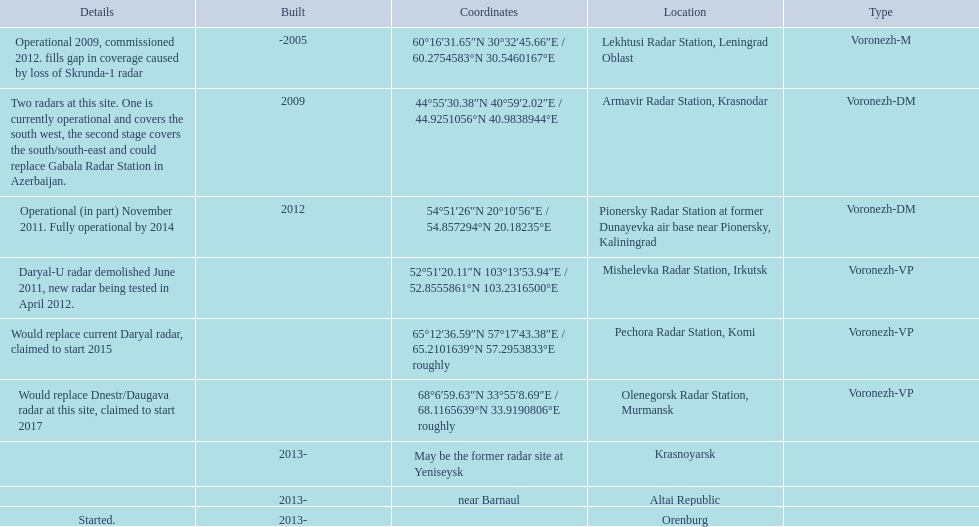What are all of the locations? Lekhtusi Radar Station, Leningrad Oblast, Armavir Radar Station, Krasnodar, Pionersky Radar Station at former Dunayevka air base near Pionersky, Kaliningrad, Mishelevka Radar Station, Irkutsk, Pechora Radar Station, Komi, Olenegorsk Radar Station, Murmansk, Krasnoyarsk, Altai Republic, Orenburg. Would you be able to parse every entry in this table? {'header': ['Details', 'Built', 'Coordinates', 'Location', 'Type'], 'rows': [['Operational 2009, commissioned 2012. fills gap in coverage caused by loss of Skrunda-1 radar', '-2005', '60°16′31.65″N 30°32′45.66″E\ufeff / \ufeff60.2754583°N 30.5460167°E', 'Lekhtusi Radar Station, Leningrad Oblast', 'Voronezh-M'], ['Two radars at this site. One is currently operational and covers the south west, the second stage covers the south/south-east and could replace Gabala Radar Station in Azerbaijan.', '2009', '44°55′30.38″N 40°59′2.02″E\ufeff / \ufeff44.9251056°N 40.9838944°E', 'Armavir Radar Station, Krasnodar', 'Voronezh-DM'], ['Operational (in part) November 2011. Fully operational by 2014', '2012', '54°51′26″N 20°10′56″E\ufeff / \ufeff54.857294°N 20.18235°E', 'Pionersky Radar Station at former Dunayevka air base near Pionersky, Kaliningrad', 'Voronezh-DM'], ['Daryal-U radar demolished June 2011, new radar being tested in April 2012.', '', '52°51′20.11″N 103°13′53.94″E\ufeff / \ufeff52.8555861°N 103.2316500°E', 'Mishelevka Radar Station, Irkutsk', 'Voronezh-VP'], ['Would replace current Daryal radar, claimed to start 2015', '', '65°12′36.59″N 57°17′43.38″E\ufeff / \ufeff65.2101639°N 57.2953833°E roughly', 'Pechora Radar Station, Komi', 'Voronezh-VP'], ['Would replace Dnestr/Daugava radar at this site, claimed to start 2017', '', '68°6′59.63″N 33°55′8.69″E\ufeff / \ufeff68.1165639°N 33.9190806°E roughly', 'Olenegorsk Radar Station, Murmansk', 'Voronezh-VP'], ['', '2013-', 'May be the former radar site at Yeniseysk', 'Krasnoyarsk', ''], ['', '2013-', 'near Barnaul', 'Altai Republic', ''], ['Started.', '2013-', '', 'Orenburg', '']]} And which location's coordinates are 60deg16'31.65''n 30deg32'45.66''e / 60.2754583degn 30.5460167dege? Lekhtusi Radar Station, Leningrad Oblast. 